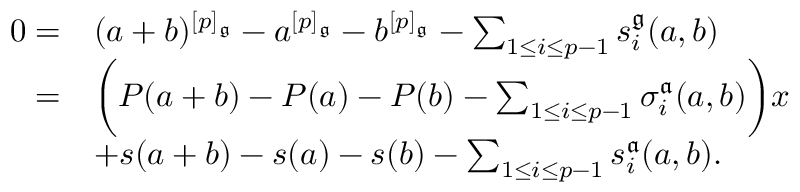Convert formula to latex. <formula><loc_0><loc_0><loc_500><loc_500>\begin{array} { r l } { 0 = } & { ( a + b ) ^ { [ p ] _ { \mathfrak { g } } } - a ^ { [ p ] _ { \mathfrak { g } } } - b ^ { [ p ] _ { \mathfrak { g } } } - \sum _ { 1 \leq i \leq p - 1 } s _ { i } ^ { \mathfrak { g } } ( a , b ) } \\ { = } & { \left ( P ( a + b ) - P ( a ) - P ( b ) - \sum _ { 1 \leq i \leq p - 1 } \sigma _ { i } ^ { \mathfrak { a } } ( a , b ) \right ) x } \\ & { + s ( a + b ) - s ( a ) - s ( b ) - \sum _ { 1 \leq i \leq p - 1 } s _ { i } ^ { \mathfrak { a } } ( a , b ) . } \end{array}</formula> 